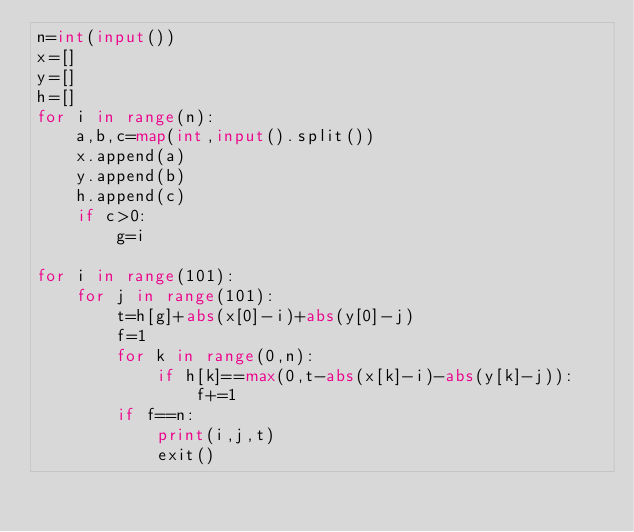Convert code to text. <code><loc_0><loc_0><loc_500><loc_500><_Python_>n=int(input())
x=[]
y=[]
h=[]
for i in range(n):
    a,b,c=map(int,input().split())
    x.append(a)
    y.append(b)
    h.append(c)
    if c>0:
        g=i

for i in range(101):
    for j in range(101):
        t=h[g]+abs(x[0]-i)+abs(y[0]-j)
        f=1
        for k in range(0,n):
            if h[k]==max(0,t-abs(x[k]-i)-abs(y[k]-j)):
                f+=1
        if f==n:
            print(i,j,t)
            exit()
        
</code> 